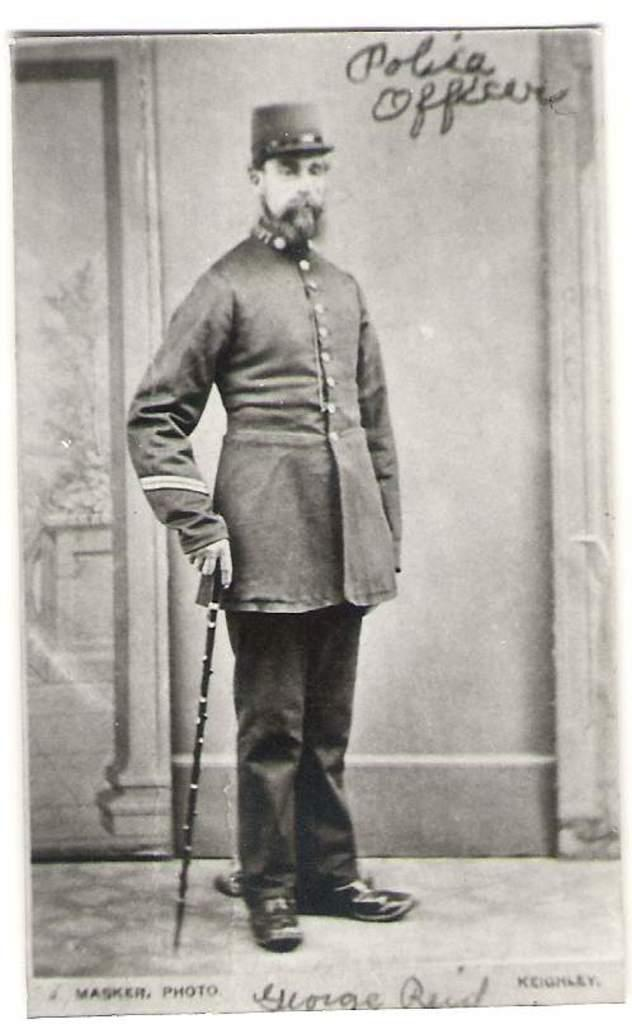<image>
Summarize the visual content of the image. A black and white photo of a man says Police Officer on it. 